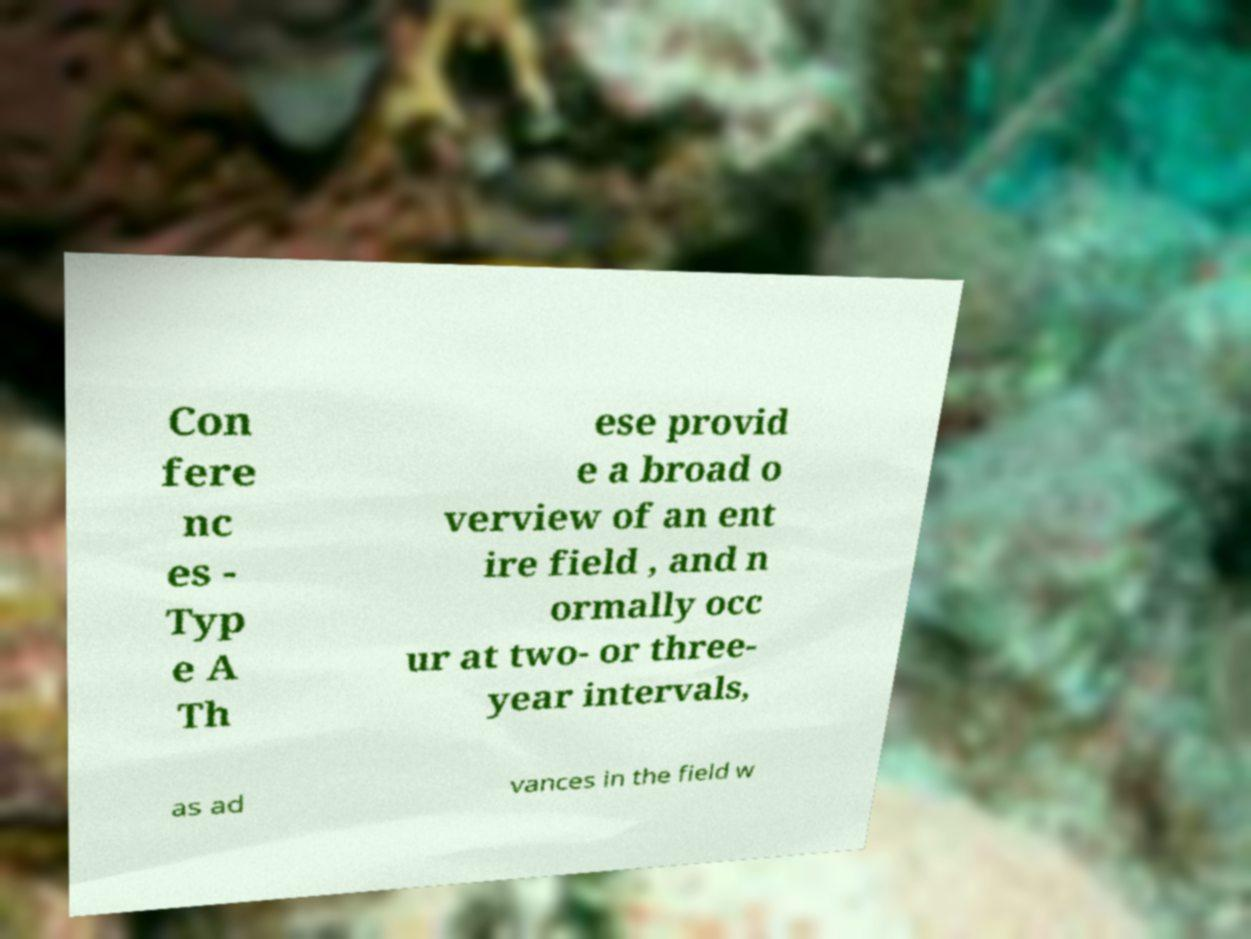There's text embedded in this image that I need extracted. Can you transcribe it verbatim? Con fere nc es - Typ e A Th ese provid e a broad o verview of an ent ire field , and n ormally occ ur at two- or three- year intervals, as ad vances in the field w 